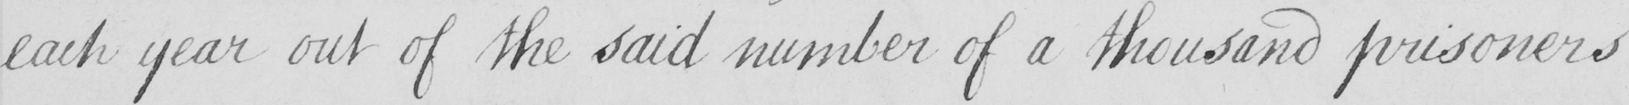Transcribe the text shown in this historical manuscript line. each year out of the said number of a thousand prisoners 